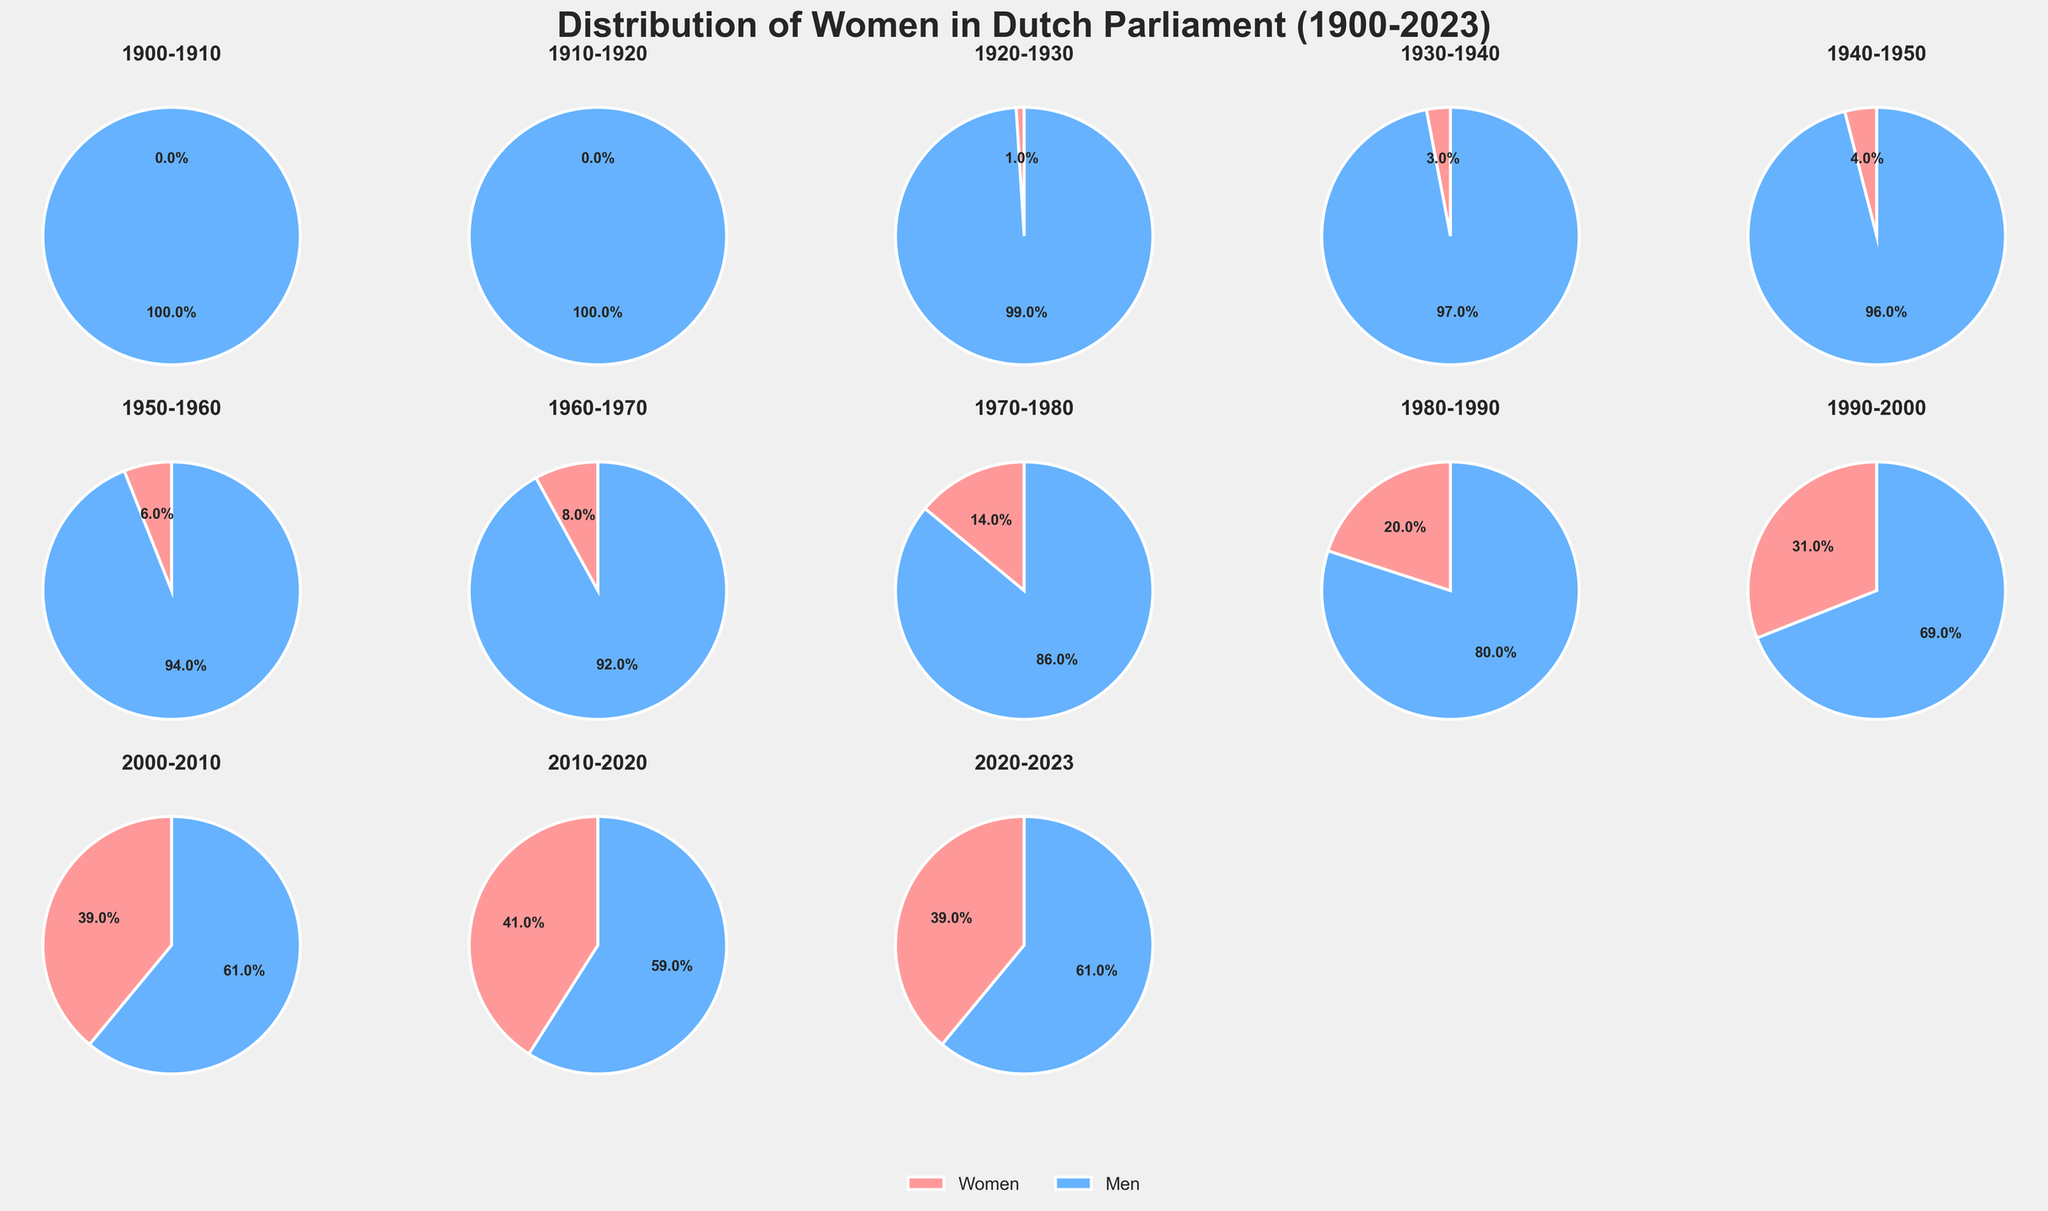What's the percentage of women in Dutch parliament in the 1920-1930 decade? In the 1920-1930 decade, the pie chart shows 1% for women. This is directly visible in the figure, where the women portion is highlighted with the respective percentage label.
Answer: 1% Which decade shows the highest increase in the percentage of women in parliament compared to the previous decade? By examining each pie chart and comparing the percentages, the 1990-2000 decade shows the highest increase, where women increased from 20% to 31%, an 11% increase.
Answer: 1990-2000 What is the median percentage of women in the Dutch parliament over the decades shown? The percentages of women in each decade are: 0, 0, 1, 3, 4, 6, 8, 14, 20, 31, 39, 41, 39. Arranging these in order gives: 0, 0, 1, 3, 4, 6, 8, 14, 20, 31, 39, 39, 41. The middle value (median) is the 8th number: 14.
Answer: 14% Which decade had the smallest percentage of men in parliament? The pie chart for the 2010-2020 decade shows the smallest percentage of men at 59%.
Answer: 2010-2020 How does the percentage of women in the decade 2010-2020 compare to that in 2000-2010? The percentage of women in the 2000-2010 decade is 39%, while in the 2010-2020 decade it rises to 41%. Comparing these, women have a 2% increase in the later decade.
Answer: 2% increase Which decade saw the percentage of women reaching double digits for the first time? Reviewing the pie charts, the 1970-1980 decade shows 14%, the first instance of the percentage reaching double digits.
Answer: 1970-1980 What's the average percentage of men in parliament across all decades shown in the plot? Sum the percentages of men for each decade: 100, 100, 99, 97, 96, 94, 92, 86, 80, 69, 61, 59, 61. Average = (100 + 100 + 99 + 97 + 96 + 94 + 92 + 86 + 80 + 69 + 61 + 59 + 61) / 13 = 88%.
Answer: 88% In which decade is the percentage split between men and women closest to 50-50? The closest decade to a 50-50 split is 2010-2020 with 41% women and 59% men.
Answer: 2010-2020 